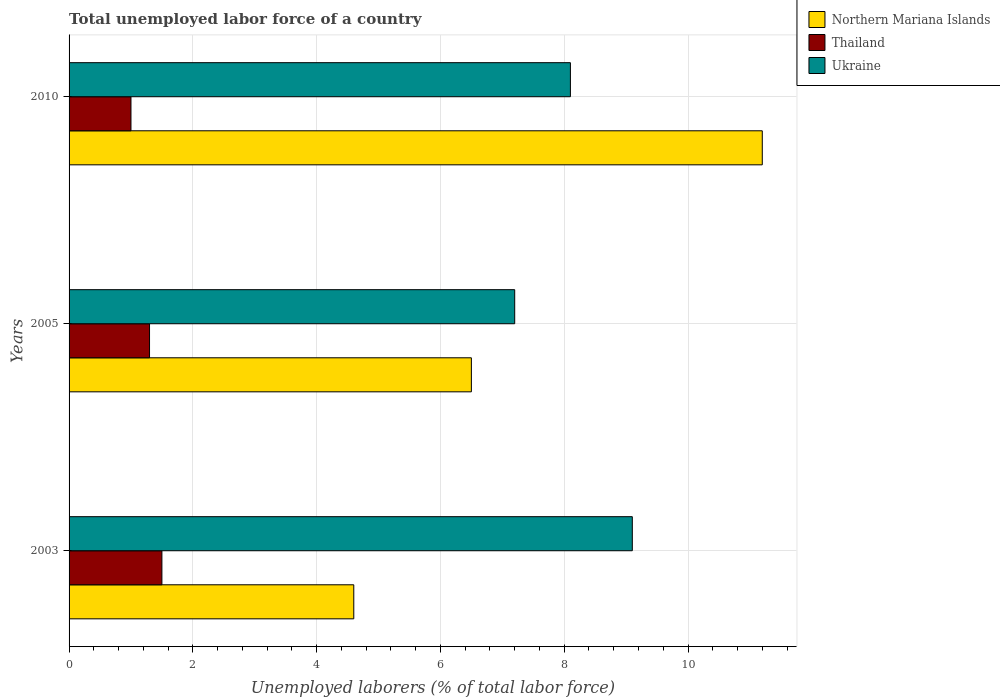How many different coloured bars are there?
Provide a short and direct response. 3. How many groups of bars are there?
Your response must be concise. 3. Are the number of bars per tick equal to the number of legend labels?
Ensure brevity in your answer.  Yes. Are the number of bars on each tick of the Y-axis equal?
Ensure brevity in your answer.  Yes. How many bars are there on the 1st tick from the top?
Offer a very short reply. 3. In how many cases, is the number of bars for a given year not equal to the number of legend labels?
Give a very brief answer. 0. Across all years, what is the maximum total unemployed labor force in Northern Mariana Islands?
Ensure brevity in your answer.  11.2. Across all years, what is the minimum total unemployed labor force in Northern Mariana Islands?
Make the answer very short. 4.6. In which year was the total unemployed labor force in Thailand maximum?
Give a very brief answer. 2003. What is the total total unemployed labor force in Thailand in the graph?
Keep it short and to the point. 3.8. What is the difference between the total unemployed labor force in Northern Mariana Islands in 2005 and the total unemployed labor force in Ukraine in 2003?
Ensure brevity in your answer.  -2.6. What is the average total unemployed labor force in Thailand per year?
Your answer should be compact. 1.27. In the year 2010, what is the difference between the total unemployed labor force in Thailand and total unemployed labor force in Ukraine?
Your answer should be very brief. -7.1. In how many years, is the total unemployed labor force in Thailand greater than 10.4 %?
Offer a very short reply. 0. What is the ratio of the total unemployed labor force in Thailand in 2003 to that in 2010?
Give a very brief answer. 1.5. Is the total unemployed labor force in Northern Mariana Islands in 2003 less than that in 2010?
Your response must be concise. Yes. Is the difference between the total unemployed labor force in Thailand in 2003 and 2005 greater than the difference between the total unemployed labor force in Ukraine in 2003 and 2005?
Provide a short and direct response. No. What is the difference between the highest and the second highest total unemployed labor force in Northern Mariana Islands?
Ensure brevity in your answer.  4.7. What is the difference between the highest and the lowest total unemployed labor force in Ukraine?
Provide a succinct answer. 1.9. Is the sum of the total unemployed labor force in Thailand in 2003 and 2010 greater than the maximum total unemployed labor force in Northern Mariana Islands across all years?
Your answer should be very brief. No. What does the 1st bar from the top in 2010 represents?
Make the answer very short. Ukraine. What does the 2nd bar from the bottom in 2005 represents?
Make the answer very short. Thailand. How many bars are there?
Offer a very short reply. 9. Are all the bars in the graph horizontal?
Your answer should be very brief. Yes. How many years are there in the graph?
Provide a succinct answer. 3. What is the difference between two consecutive major ticks on the X-axis?
Keep it short and to the point. 2. Does the graph contain any zero values?
Ensure brevity in your answer.  No. Where does the legend appear in the graph?
Your answer should be very brief. Top right. How many legend labels are there?
Ensure brevity in your answer.  3. How are the legend labels stacked?
Your answer should be compact. Vertical. What is the title of the graph?
Keep it short and to the point. Total unemployed labor force of a country. What is the label or title of the X-axis?
Provide a succinct answer. Unemployed laborers (% of total labor force). What is the label or title of the Y-axis?
Provide a short and direct response. Years. What is the Unemployed laborers (% of total labor force) in Northern Mariana Islands in 2003?
Your answer should be very brief. 4.6. What is the Unemployed laborers (% of total labor force) in Ukraine in 2003?
Ensure brevity in your answer.  9.1. What is the Unemployed laborers (% of total labor force) of Northern Mariana Islands in 2005?
Offer a very short reply. 6.5. What is the Unemployed laborers (% of total labor force) of Thailand in 2005?
Keep it short and to the point. 1.3. What is the Unemployed laborers (% of total labor force) in Ukraine in 2005?
Make the answer very short. 7.2. What is the Unemployed laborers (% of total labor force) of Northern Mariana Islands in 2010?
Your answer should be very brief. 11.2. What is the Unemployed laborers (% of total labor force) in Thailand in 2010?
Offer a terse response. 1. What is the Unemployed laborers (% of total labor force) in Ukraine in 2010?
Offer a terse response. 8.1. Across all years, what is the maximum Unemployed laborers (% of total labor force) in Northern Mariana Islands?
Your response must be concise. 11.2. Across all years, what is the maximum Unemployed laborers (% of total labor force) in Thailand?
Ensure brevity in your answer.  1.5. Across all years, what is the maximum Unemployed laborers (% of total labor force) of Ukraine?
Provide a short and direct response. 9.1. Across all years, what is the minimum Unemployed laborers (% of total labor force) in Northern Mariana Islands?
Keep it short and to the point. 4.6. Across all years, what is the minimum Unemployed laborers (% of total labor force) of Thailand?
Your answer should be very brief. 1. Across all years, what is the minimum Unemployed laborers (% of total labor force) in Ukraine?
Give a very brief answer. 7.2. What is the total Unemployed laborers (% of total labor force) of Northern Mariana Islands in the graph?
Provide a short and direct response. 22.3. What is the total Unemployed laborers (% of total labor force) in Thailand in the graph?
Provide a short and direct response. 3.8. What is the total Unemployed laborers (% of total labor force) in Ukraine in the graph?
Offer a very short reply. 24.4. What is the difference between the Unemployed laborers (% of total labor force) in Thailand in 2003 and that in 2005?
Ensure brevity in your answer.  0.2. What is the difference between the Unemployed laborers (% of total labor force) of Northern Mariana Islands in 2003 and the Unemployed laborers (% of total labor force) of Thailand in 2005?
Your answer should be compact. 3.3. What is the difference between the Unemployed laborers (% of total labor force) in Northern Mariana Islands in 2003 and the Unemployed laborers (% of total labor force) in Thailand in 2010?
Give a very brief answer. 3.6. What is the difference between the Unemployed laborers (% of total labor force) of Thailand in 2003 and the Unemployed laborers (% of total labor force) of Ukraine in 2010?
Provide a succinct answer. -6.6. What is the difference between the Unemployed laborers (% of total labor force) in Thailand in 2005 and the Unemployed laborers (% of total labor force) in Ukraine in 2010?
Make the answer very short. -6.8. What is the average Unemployed laborers (% of total labor force) in Northern Mariana Islands per year?
Offer a very short reply. 7.43. What is the average Unemployed laborers (% of total labor force) of Thailand per year?
Provide a short and direct response. 1.27. What is the average Unemployed laborers (% of total labor force) in Ukraine per year?
Ensure brevity in your answer.  8.13. In the year 2003, what is the difference between the Unemployed laborers (% of total labor force) of Northern Mariana Islands and Unemployed laborers (% of total labor force) of Thailand?
Your answer should be compact. 3.1. In the year 2003, what is the difference between the Unemployed laborers (% of total labor force) in Northern Mariana Islands and Unemployed laborers (% of total labor force) in Ukraine?
Your answer should be very brief. -4.5. In the year 2005, what is the difference between the Unemployed laborers (% of total labor force) of Northern Mariana Islands and Unemployed laborers (% of total labor force) of Thailand?
Give a very brief answer. 5.2. In the year 2005, what is the difference between the Unemployed laborers (% of total labor force) in Thailand and Unemployed laborers (% of total labor force) in Ukraine?
Ensure brevity in your answer.  -5.9. In the year 2010, what is the difference between the Unemployed laborers (% of total labor force) in Northern Mariana Islands and Unemployed laborers (% of total labor force) in Thailand?
Provide a succinct answer. 10.2. In the year 2010, what is the difference between the Unemployed laborers (% of total labor force) of Northern Mariana Islands and Unemployed laborers (% of total labor force) of Ukraine?
Your response must be concise. 3.1. What is the ratio of the Unemployed laborers (% of total labor force) of Northern Mariana Islands in 2003 to that in 2005?
Give a very brief answer. 0.71. What is the ratio of the Unemployed laborers (% of total labor force) in Thailand in 2003 to that in 2005?
Provide a short and direct response. 1.15. What is the ratio of the Unemployed laborers (% of total labor force) in Ukraine in 2003 to that in 2005?
Ensure brevity in your answer.  1.26. What is the ratio of the Unemployed laborers (% of total labor force) of Northern Mariana Islands in 2003 to that in 2010?
Your answer should be compact. 0.41. What is the ratio of the Unemployed laborers (% of total labor force) in Ukraine in 2003 to that in 2010?
Offer a very short reply. 1.12. What is the ratio of the Unemployed laborers (% of total labor force) of Northern Mariana Islands in 2005 to that in 2010?
Your answer should be very brief. 0.58. What is the difference between the highest and the second highest Unemployed laborers (% of total labor force) of Northern Mariana Islands?
Offer a very short reply. 4.7. What is the difference between the highest and the lowest Unemployed laborers (% of total labor force) of Northern Mariana Islands?
Keep it short and to the point. 6.6. 